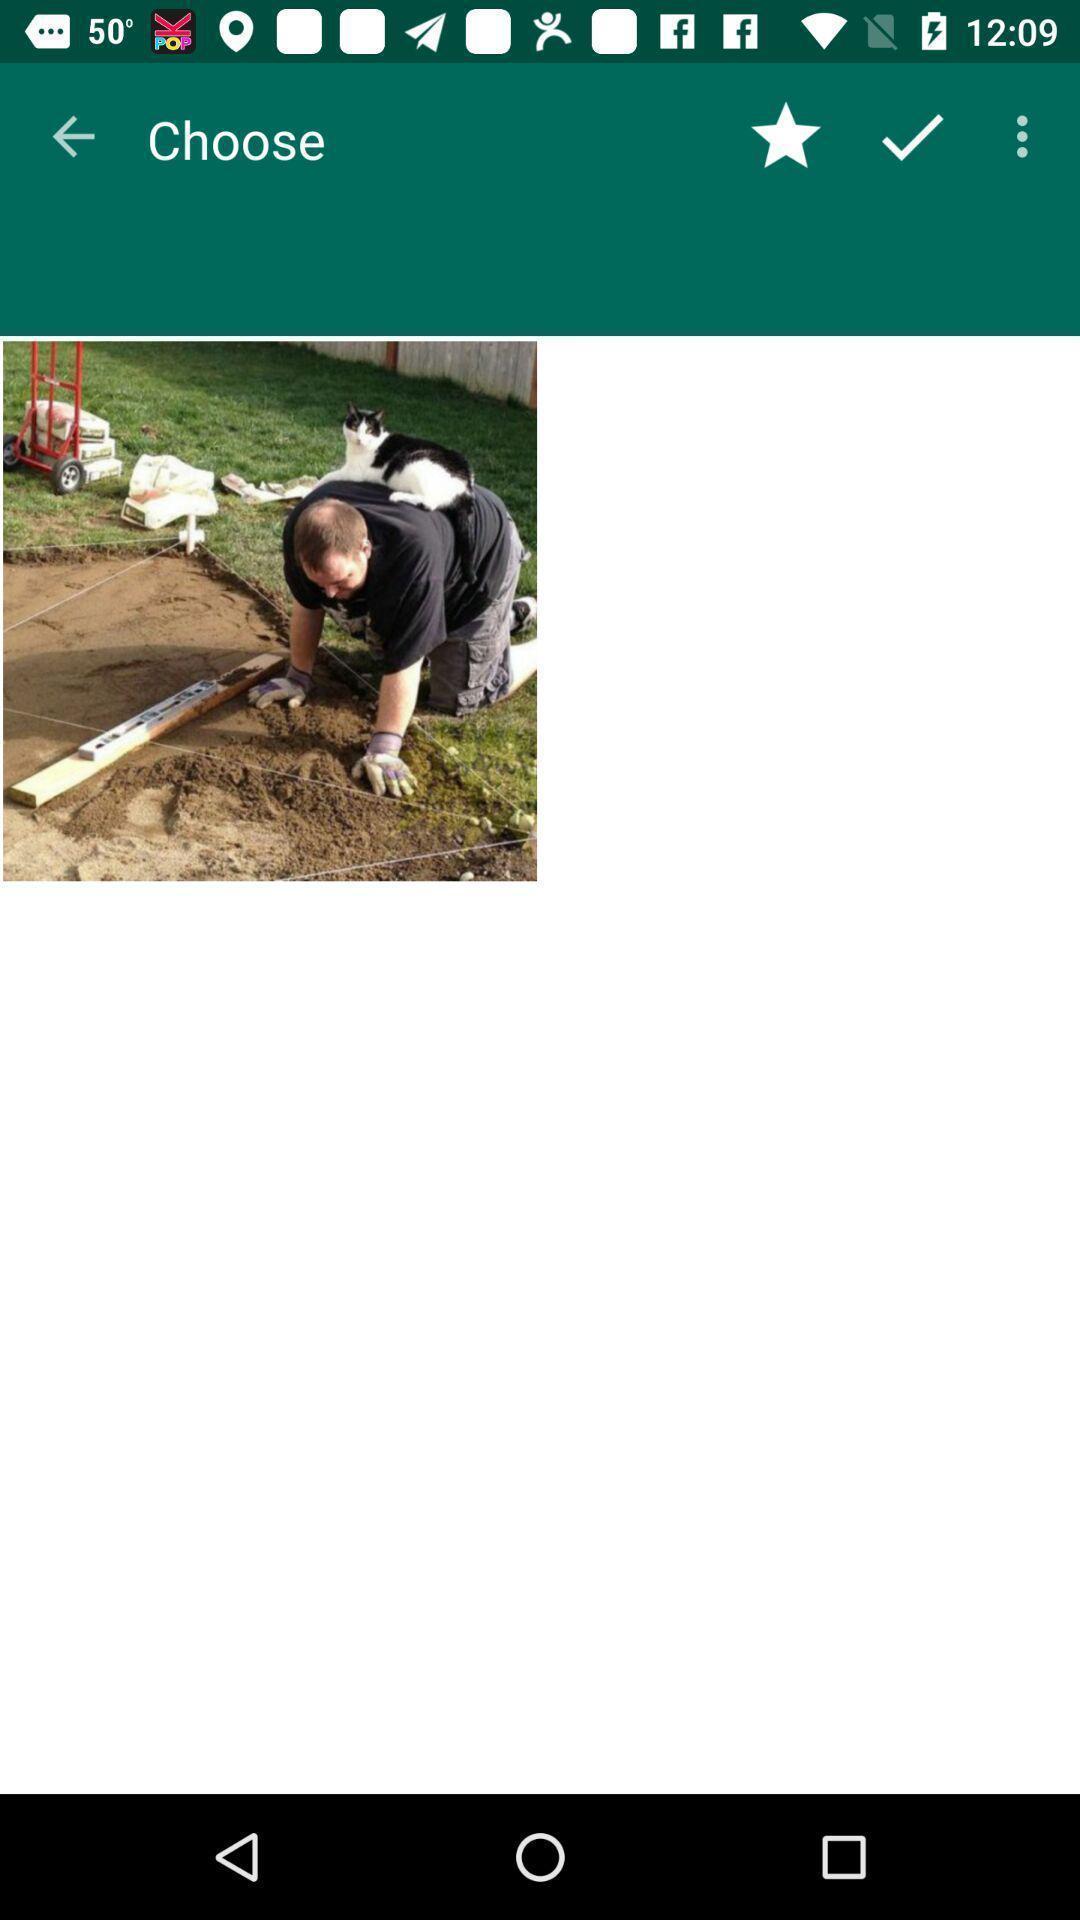Describe the visual elements of this screenshot. Screen shows to choose a photo. 